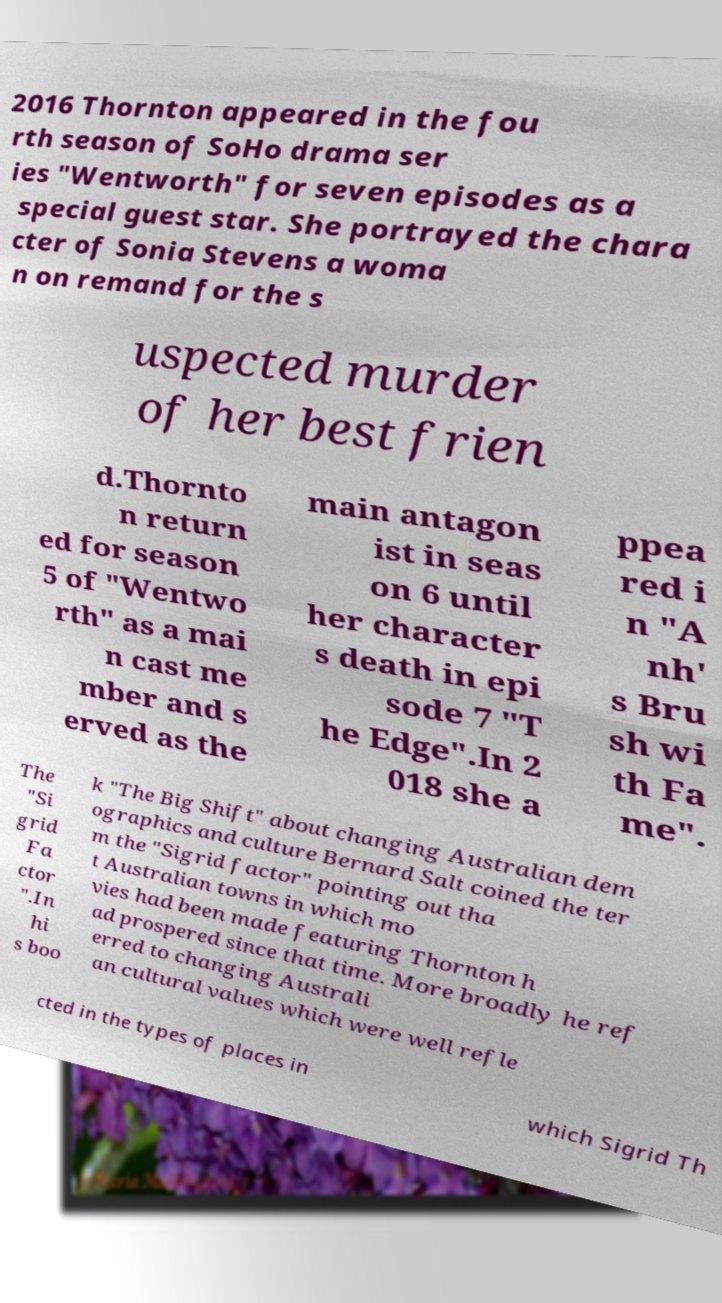I need the written content from this picture converted into text. Can you do that? 2016 Thornton appeared in the fou rth season of SoHo drama ser ies "Wentworth" for seven episodes as a special guest star. She portrayed the chara cter of Sonia Stevens a woma n on remand for the s uspected murder of her best frien d.Thornto n return ed for season 5 of "Wentwo rth" as a mai n cast me mber and s erved as the main antagon ist in seas on 6 until her character s death in epi sode 7 "T he Edge".In 2 018 she a ppea red i n "A nh' s Bru sh wi th Fa me". The "Si grid Fa ctor ".In hi s boo k "The Big Shift" about changing Australian dem ographics and culture Bernard Salt coined the ter m the "Sigrid factor" pointing out tha t Australian towns in which mo vies had been made featuring Thornton h ad prospered since that time. More broadly he ref erred to changing Australi an cultural values which were well refle cted in the types of places in which Sigrid Th 